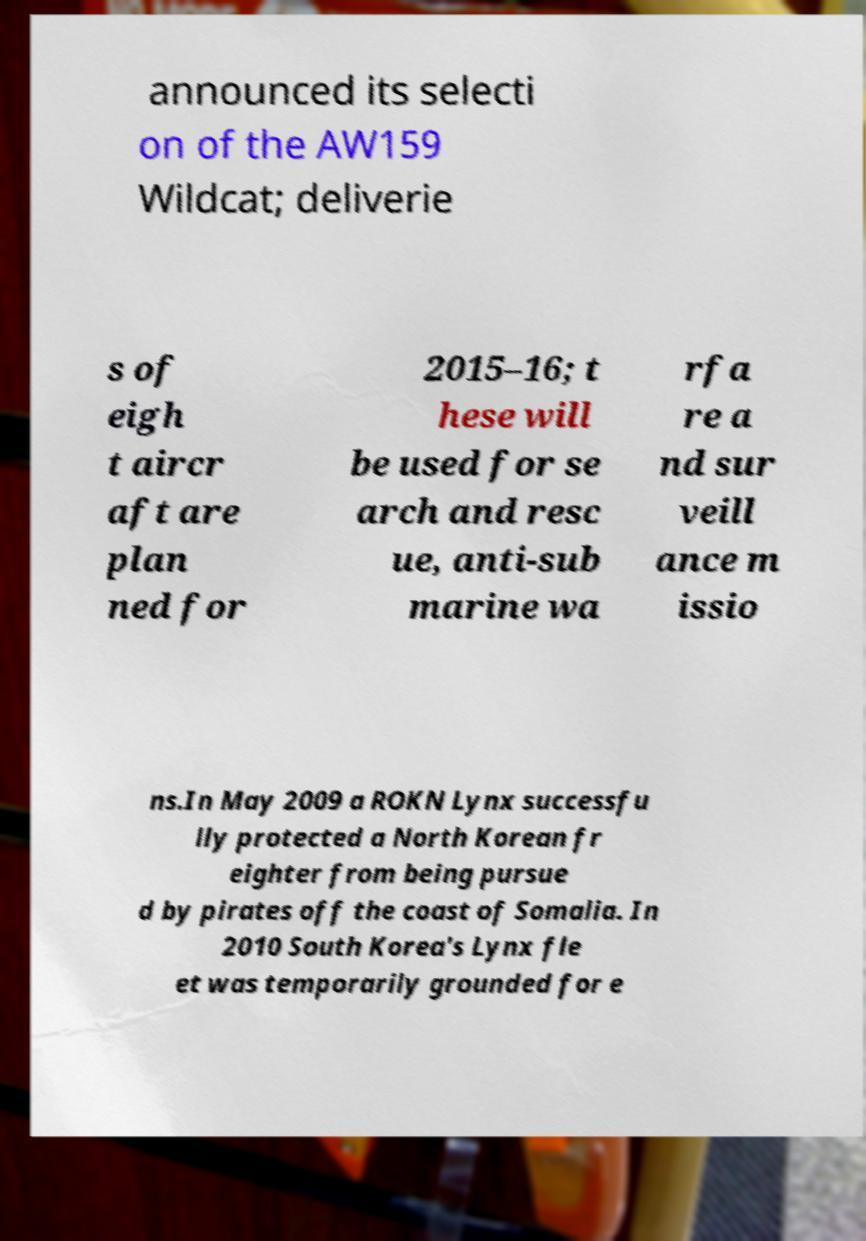For documentation purposes, I need the text within this image transcribed. Could you provide that? announced its selecti on of the AW159 Wildcat; deliverie s of eigh t aircr aft are plan ned for 2015–16; t hese will be used for se arch and resc ue, anti-sub marine wa rfa re a nd sur veill ance m issio ns.In May 2009 a ROKN Lynx successfu lly protected a North Korean fr eighter from being pursue d by pirates off the coast of Somalia. In 2010 South Korea's Lynx fle et was temporarily grounded for e 